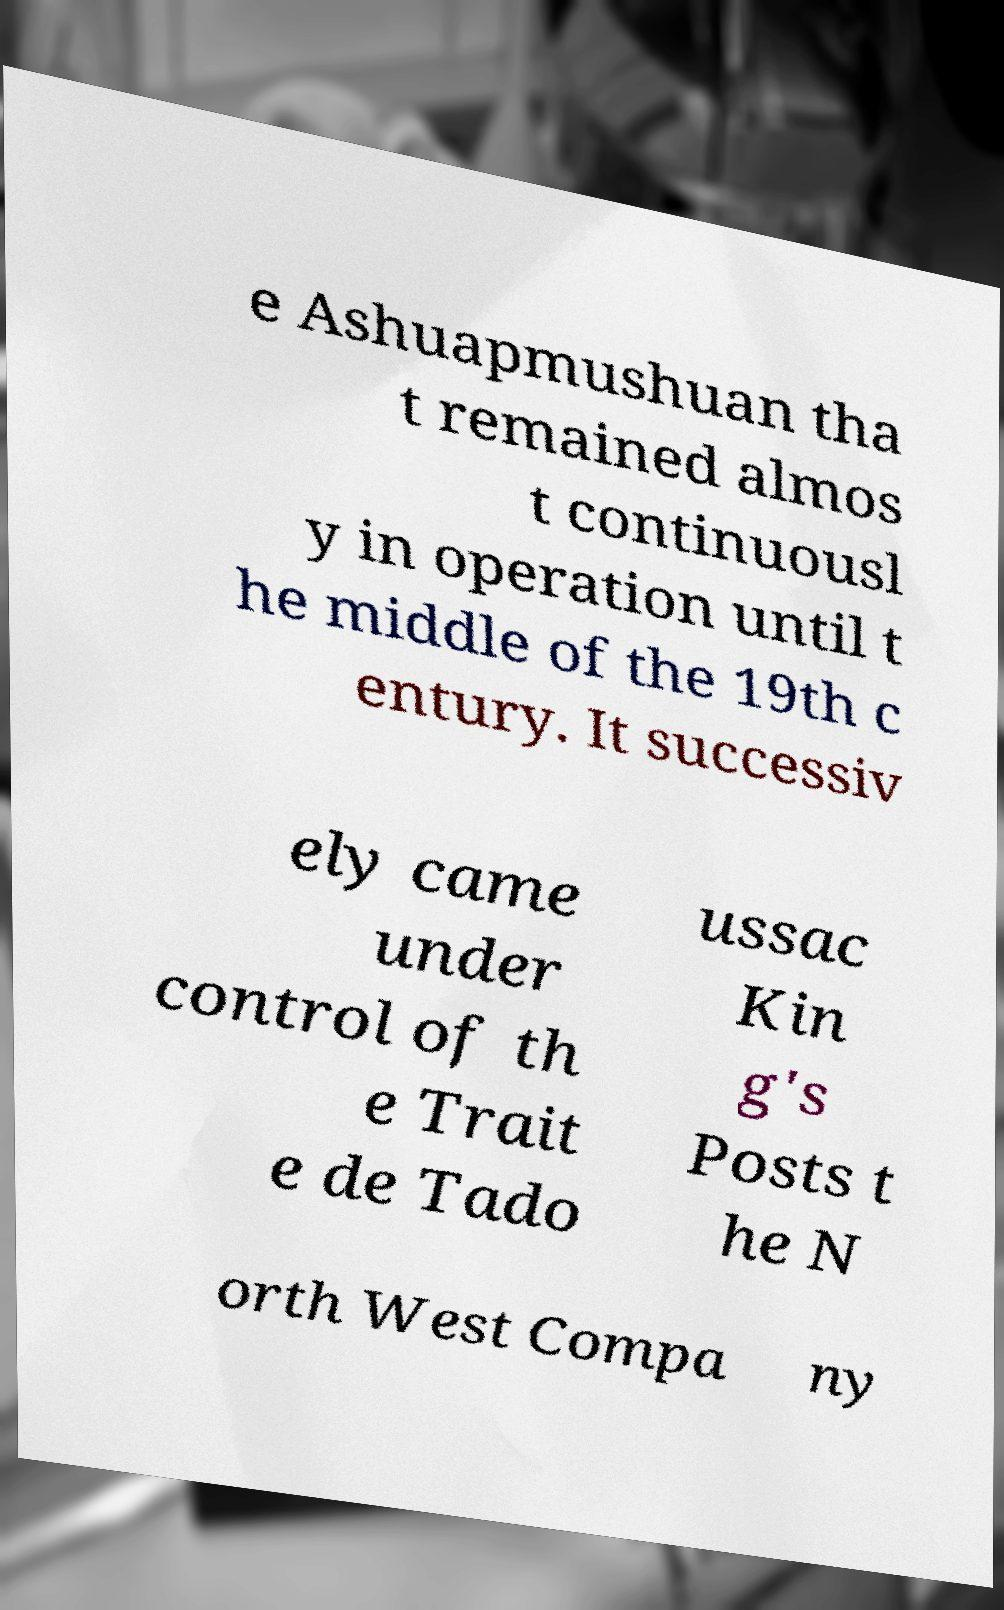Could you assist in decoding the text presented in this image and type it out clearly? e Ashuapmushuan tha t remained almos t continuousl y in operation until t he middle of the 19th c entury. It successiv ely came under control of th e Trait e de Tado ussac Kin g's Posts t he N orth West Compa ny 